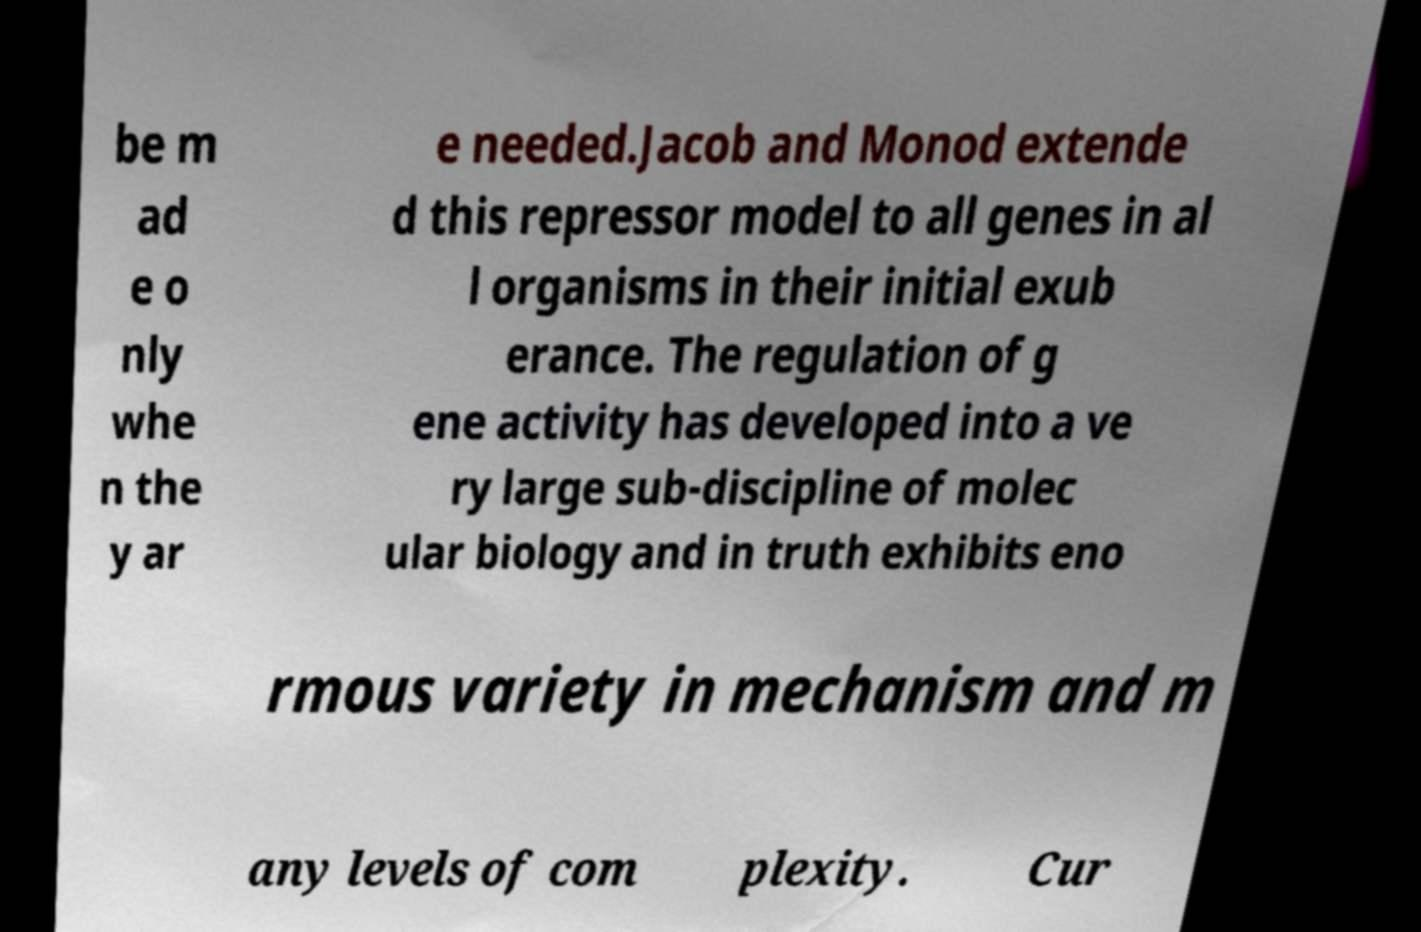Could you extract and type out the text from this image? be m ad e o nly whe n the y ar e needed.Jacob and Monod extende d this repressor model to all genes in al l organisms in their initial exub erance. The regulation of g ene activity has developed into a ve ry large sub-discipline of molec ular biology and in truth exhibits eno rmous variety in mechanism and m any levels of com plexity. Cur 